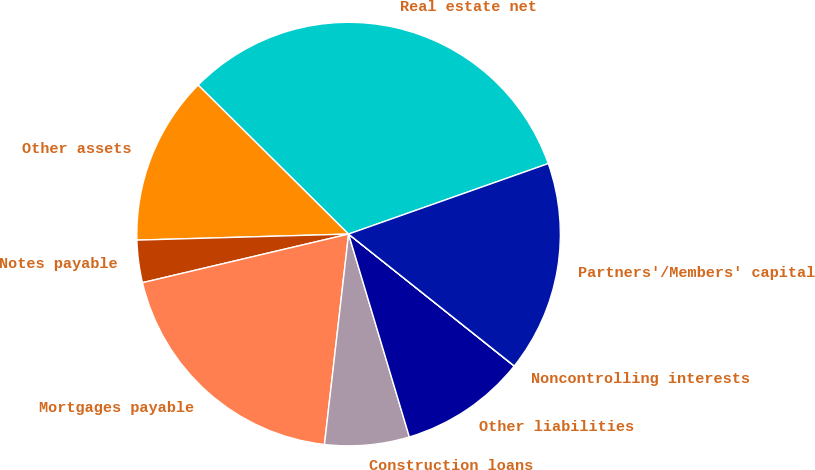<chart> <loc_0><loc_0><loc_500><loc_500><pie_chart><fcel>Real estate net<fcel>Other assets<fcel>Notes payable<fcel>Mortgages payable<fcel>Construction loans<fcel>Other liabilities<fcel>Noncontrolling interests<fcel>Partners'/Members' capital<nl><fcel>32.18%<fcel>12.88%<fcel>3.23%<fcel>19.5%<fcel>6.45%<fcel>9.66%<fcel>0.01%<fcel>16.1%<nl></chart> 